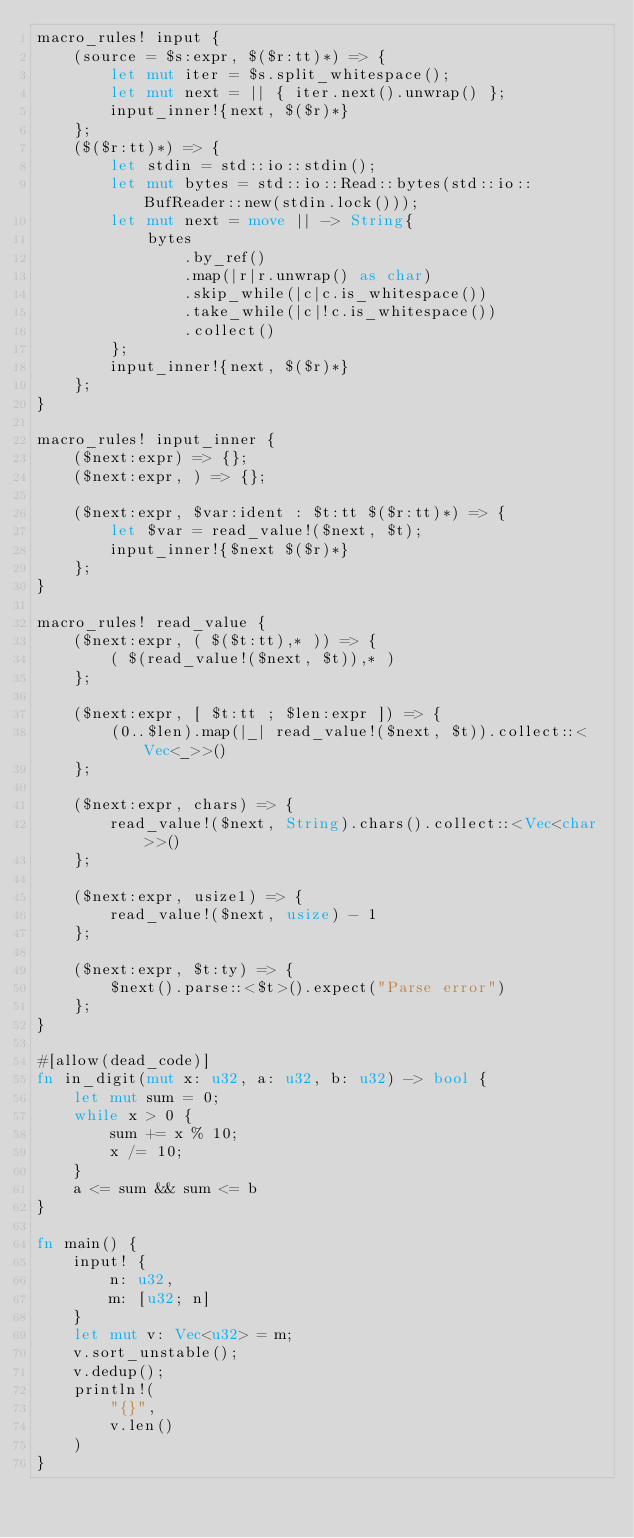Convert code to text. <code><loc_0><loc_0><loc_500><loc_500><_Rust_>macro_rules! input {
    (source = $s:expr, $($r:tt)*) => {
        let mut iter = $s.split_whitespace();
        let mut next = || { iter.next().unwrap() };
        input_inner!{next, $($r)*}
    };
    ($($r:tt)*) => {
        let stdin = std::io::stdin();
        let mut bytes = std::io::Read::bytes(std::io::BufReader::new(stdin.lock()));
        let mut next = move || -> String{
            bytes
                .by_ref()
                .map(|r|r.unwrap() as char)
                .skip_while(|c|c.is_whitespace())
                .take_while(|c|!c.is_whitespace())
                .collect()
        };
        input_inner!{next, $($r)*}
    };
}

macro_rules! input_inner {
    ($next:expr) => {};
    ($next:expr, ) => {};

    ($next:expr, $var:ident : $t:tt $($r:tt)*) => {
        let $var = read_value!($next, $t);
        input_inner!{$next $($r)*}
    };
}

macro_rules! read_value {
    ($next:expr, ( $($t:tt),* )) => {
        ( $(read_value!($next, $t)),* )
    };

    ($next:expr, [ $t:tt ; $len:expr ]) => {
        (0..$len).map(|_| read_value!($next, $t)).collect::<Vec<_>>()
    };

    ($next:expr, chars) => {
        read_value!($next, String).chars().collect::<Vec<char>>()
    };

    ($next:expr, usize1) => {
        read_value!($next, usize) - 1
    };

    ($next:expr, $t:ty) => {
        $next().parse::<$t>().expect("Parse error")
    };
}

#[allow(dead_code)]
fn in_digit(mut x: u32, a: u32, b: u32) -> bool {
    let mut sum = 0;
    while x > 0 {
        sum += x % 10;
        x /= 10;
    }
    a <= sum && sum <= b
}

fn main() {
    input! {
        n: u32,
        m: [u32; n]
    }
    let mut v: Vec<u32> = m;
    v.sort_unstable();
    v.dedup();
    println!(
        "{}",
        v.len()
    )
}
</code> 